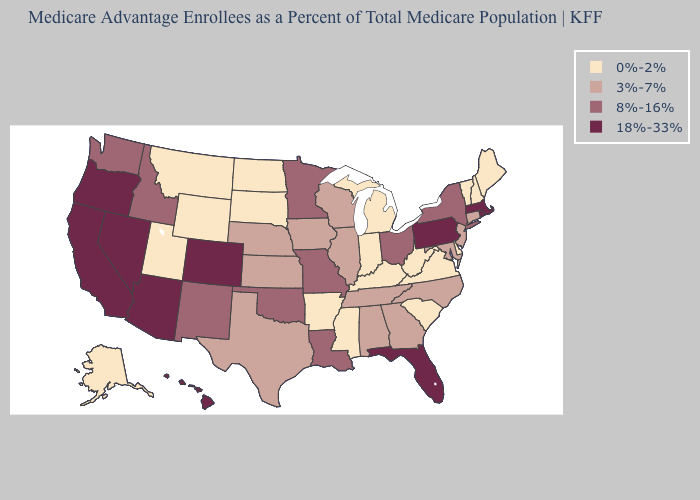Which states have the highest value in the USA?
Write a very short answer. Arizona, California, Colorado, Florida, Hawaii, Massachusetts, Nevada, Oregon, Pennsylvania, Rhode Island. Name the states that have a value in the range 18%-33%?
Answer briefly. Arizona, California, Colorado, Florida, Hawaii, Massachusetts, Nevada, Oregon, Pennsylvania, Rhode Island. What is the value of Massachusetts?
Concise answer only. 18%-33%. Does the first symbol in the legend represent the smallest category?
Write a very short answer. Yes. What is the value of Nevada?
Keep it brief. 18%-33%. Name the states that have a value in the range 18%-33%?
Keep it brief. Arizona, California, Colorado, Florida, Hawaii, Massachusetts, Nevada, Oregon, Pennsylvania, Rhode Island. What is the value of Connecticut?
Write a very short answer. 3%-7%. What is the lowest value in the USA?
Write a very short answer. 0%-2%. Among the states that border Idaho , which have the highest value?
Give a very brief answer. Nevada, Oregon. What is the highest value in the South ?
Concise answer only. 18%-33%. Among the states that border Alabama , does Florida have the highest value?
Give a very brief answer. Yes. What is the highest value in the USA?
Be succinct. 18%-33%. Name the states that have a value in the range 18%-33%?
Short answer required. Arizona, California, Colorado, Florida, Hawaii, Massachusetts, Nevada, Oregon, Pennsylvania, Rhode Island. What is the lowest value in states that border Illinois?
Concise answer only. 0%-2%. What is the value of Arkansas?
Quick response, please. 0%-2%. 